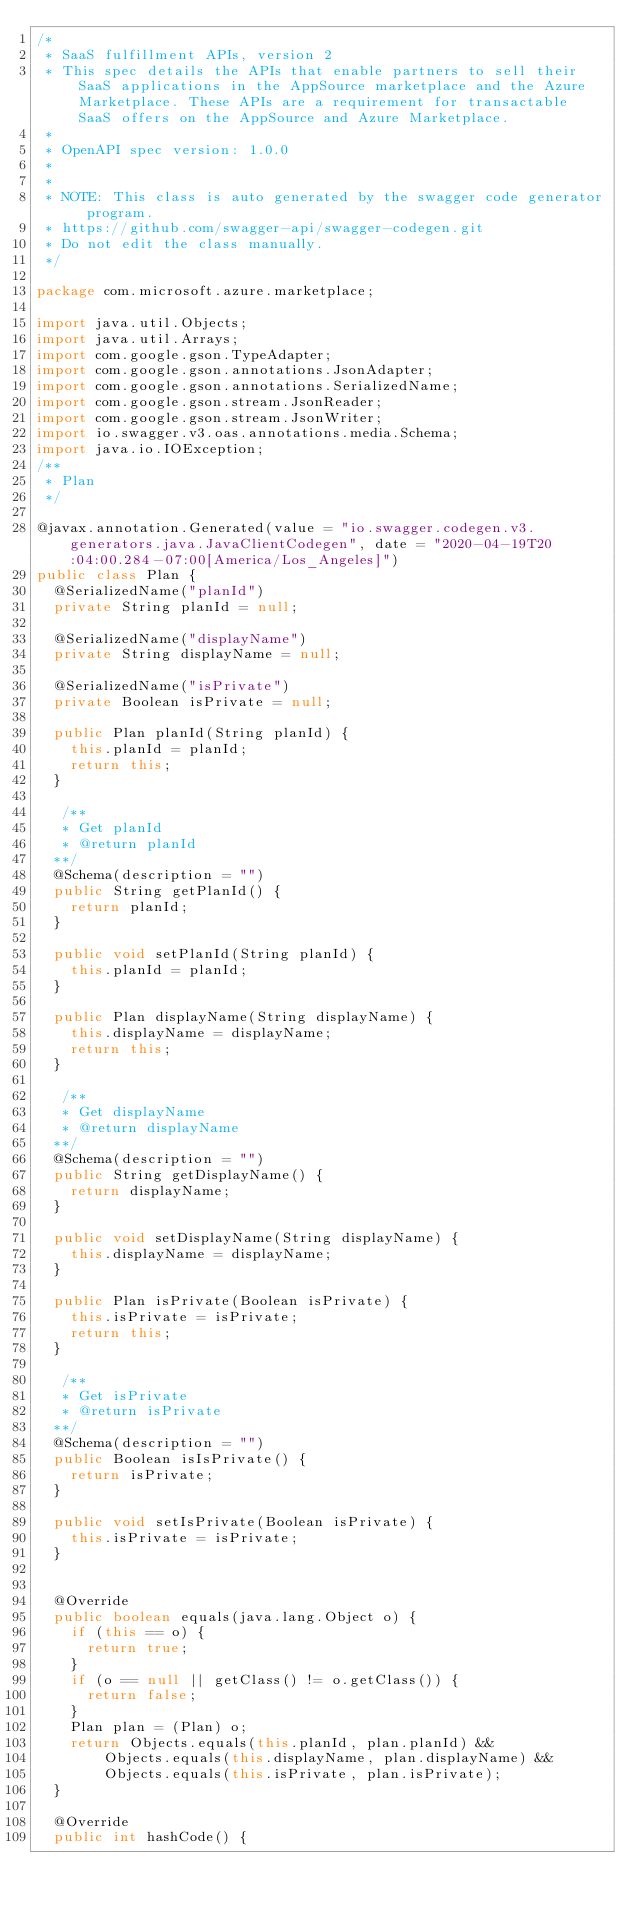Convert code to text. <code><loc_0><loc_0><loc_500><loc_500><_Java_>/*
 * SaaS fulfillment APIs, version 2
 * This spec details the APIs that enable partners to sell their SaaS applications in the AppSource marketplace and the Azure Marketplace. These APIs are a requirement for transactable SaaS offers on the AppSource and Azure Marketplace.
 *
 * OpenAPI spec version: 1.0.0
 * 
 *
 * NOTE: This class is auto generated by the swagger code generator program.
 * https://github.com/swagger-api/swagger-codegen.git
 * Do not edit the class manually.
 */

package com.microsoft.azure.marketplace;

import java.util.Objects;
import java.util.Arrays;
import com.google.gson.TypeAdapter;
import com.google.gson.annotations.JsonAdapter;
import com.google.gson.annotations.SerializedName;
import com.google.gson.stream.JsonReader;
import com.google.gson.stream.JsonWriter;
import io.swagger.v3.oas.annotations.media.Schema;
import java.io.IOException;
/**
 * Plan
 */

@javax.annotation.Generated(value = "io.swagger.codegen.v3.generators.java.JavaClientCodegen", date = "2020-04-19T20:04:00.284-07:00[America/Los_Angeles]")
public class Plan {
  @SerializedName("planId")
  private String planId = null;

  @SerializedName("displayName")
  private String displayName = null;

  @SerializedName("isPrivate")
  private Boolean isPrivate = null;

  public Plan planId(String planId) {
    this.planId = planId;
    return this;
  }

   /**
   * Get planId
   * @return planId
  **/
  @Schema(description = "")
  public String getPlanId() {
    return planId;
  }

  public void setPlanId(String planId) {
    this.planId = planId;
  }

  public Plan displayName(String displayName) {
    this.displayName = displayName;
    return this;
  }

   /**
   * Get displayName
   * @return displayName
  **/
  @Schema(description = "")
  public String getDisplayName() {
    return displayName;
  }

  public void setDisplayName(String displayName) {
    this.displayName = displayName;
  }

  public Plan isPrivate(Boolean isPrivate) {
    this.isPrivate = isPrivate;
    return this;
  }

   /**
   * Get isPrivate
   * @return isPrivate
  **/
  @Schema(description = "")
  public Boolean isIsPrivate() {
    return isPrivate;
  }

  public void setIsPrivate(Boolean isPrivate) {
    this.isPrivate = isPrivate;
  }


  @Override
  public boolean equals(java.lang.Object o) {
    if (this == o) {
      return true;
    }
    if (o == null || getClass() != o.getClass()) {
      return false;
    }
    Plan plan = (Plan) o;
    return Objects.equals(this.planId, plan.planId) &&
        Objects.equals(this.displayName, plan.displayName) &&
        Objects.equals(this.isPrivate, plan.isPrivate);
  }

  @Override
  public int hashCode() {</code> 